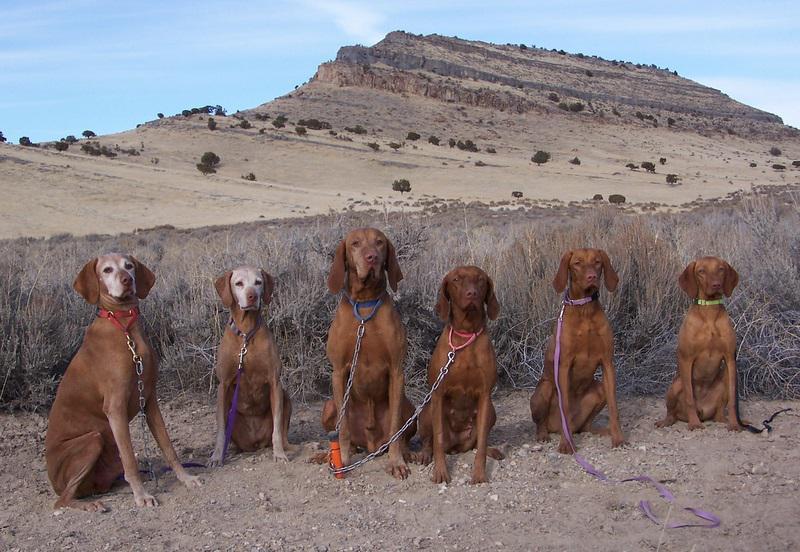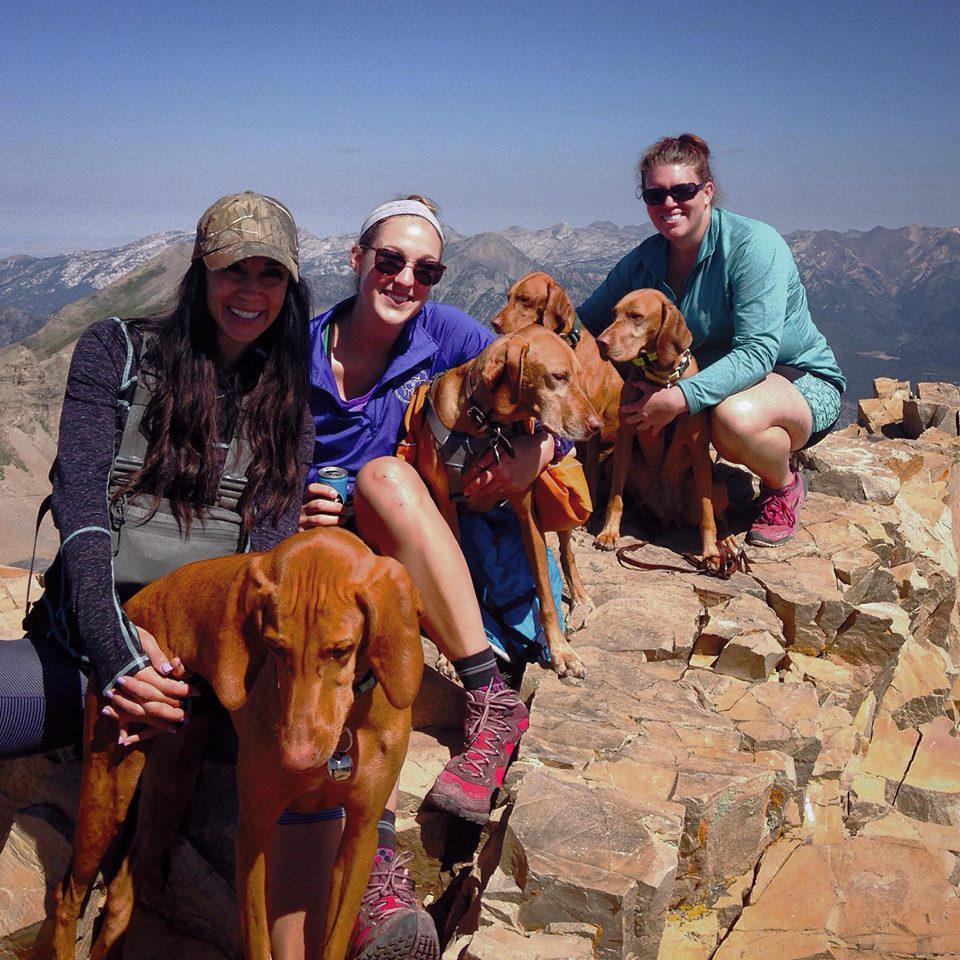The first image is the image on the left, the second image is the image on the right. Examine the images to the left and right. Is the description "In one image, exactly four dogs are at an outdoor location with one or more people." accurate? Answer yes or no. Yes. The first image is the image on the left, the second image is the image on the right. Given the left and right images, does the statement "At least some of the dogs are on a leash." hold true? Answer yes or no. Yes. 